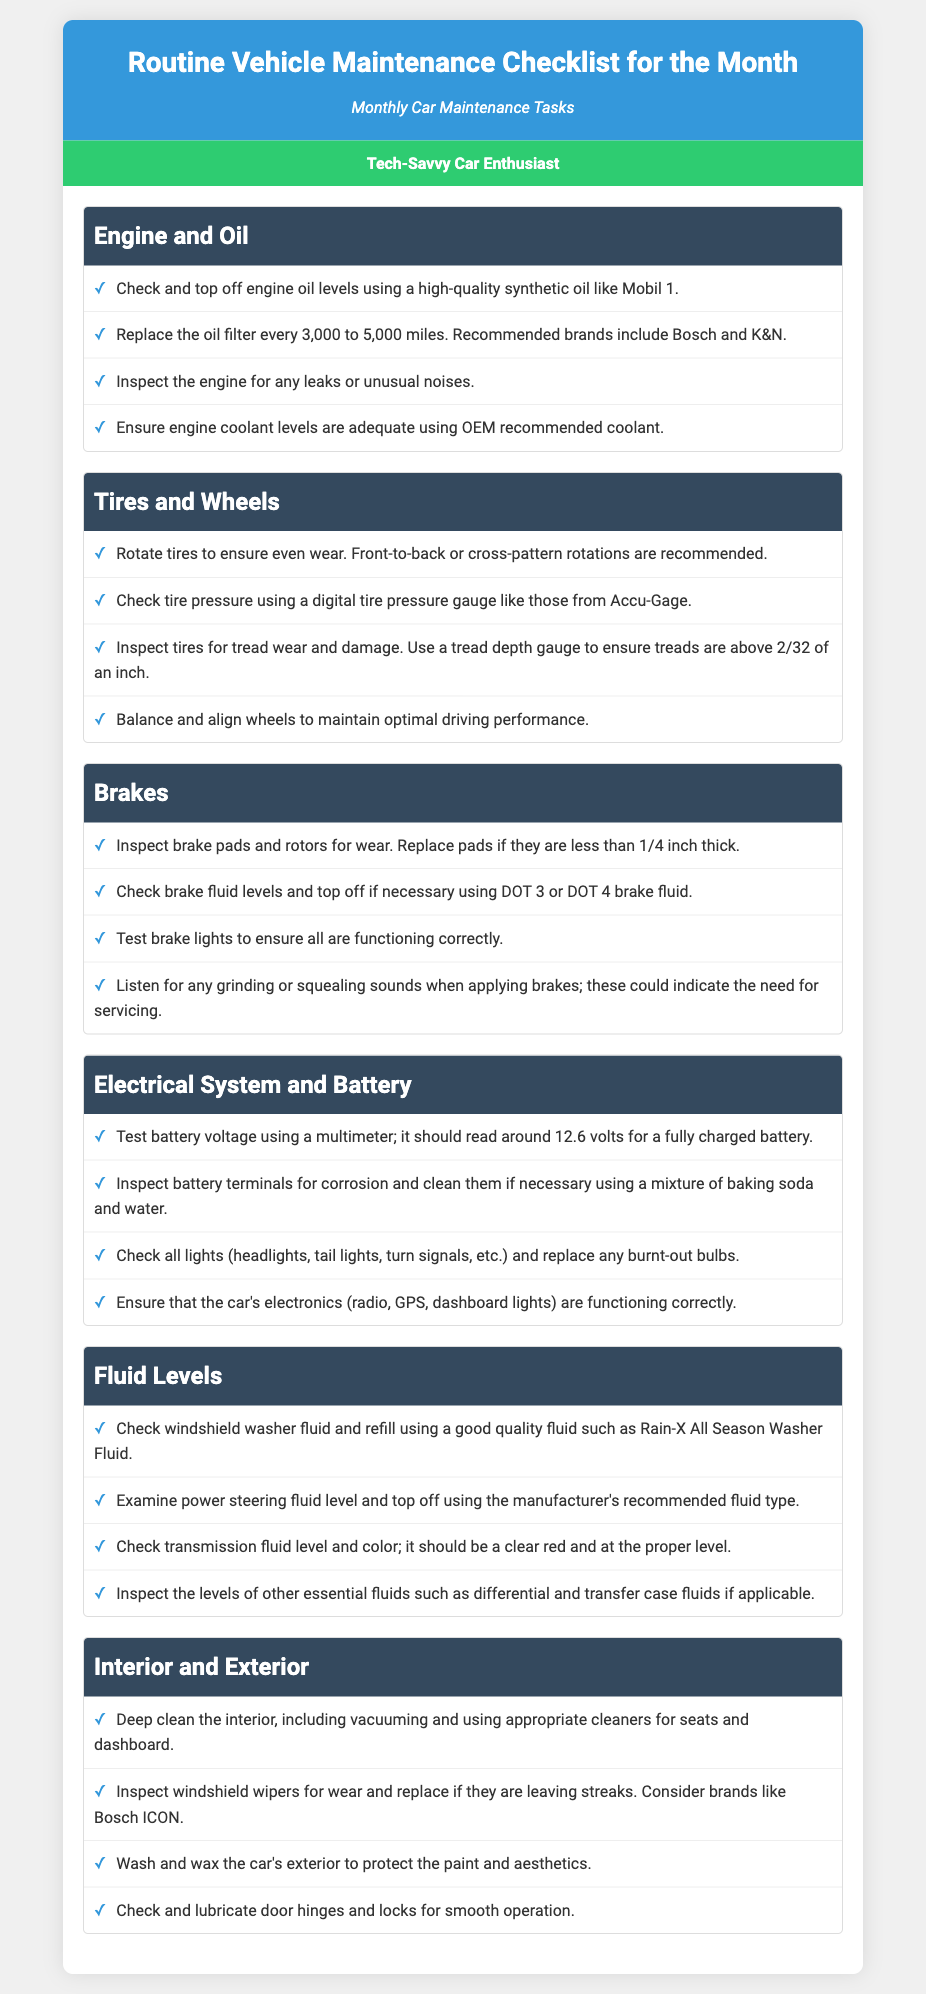What is the title of the document? The title of the document is found in the header section, summarizing the content of the checklist.
Answer: Routine Vehicle Maintenance Checklist for the Month What type of oil is recommended for topping off engine oil levels? The document mentions a specific brand and type of oil for topping off engine oil.
Answer: high-quality synthetic oil like Mobil 1 How often should the oil filter be replaced? The recommended frequency for replacing the oil filter is specified in the engine section of the checklist.
Answer: every 3,000 to 5,000 miles What should be done with the tires during this maintenance check? The checklist specifies a particular maintenance task related to the tires that should be performed monthly.
Answer: Rotate tires to ensure even wear Which brake fluid types are mentioned for topping off? The document provides specific types of brake fluid to use in case topping off is necessary.
Answer: DOT 3 or DOT 4 brake fluid What is the minimum thickness for brake pads before they need replacement? The checklist specifies a measurement related to the condition of brake pads.
Answer: less than 1/4 inch thick What kind of fluid should be checked alongside windshield washer fluid? The document lists additional fluid types that should also be examined during the maintenance check.
Answer: power steering fluid Which brand is recommended for windshield wipers? The document references a specific brand to consider for replacing worn windshield wipers.
Answer: Bosch ICON 